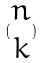Convert formula to latex. <formula><loc_0><loc_0><loc_500><loc_500>( \begin{matrix} n \\ k \end{matrix} )</formula> 